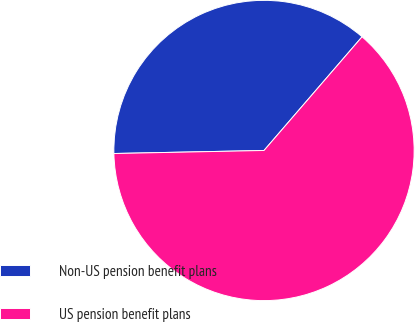Convert chart to OTSL. <chart><loc_0><loc_0><loc_500><loc_500><pie_chart><fcel>Non-US pension benefit plans<fcel>US pension benefit plans<nl><fcel>36.65%<fcel>63.35%<nl></chart> 